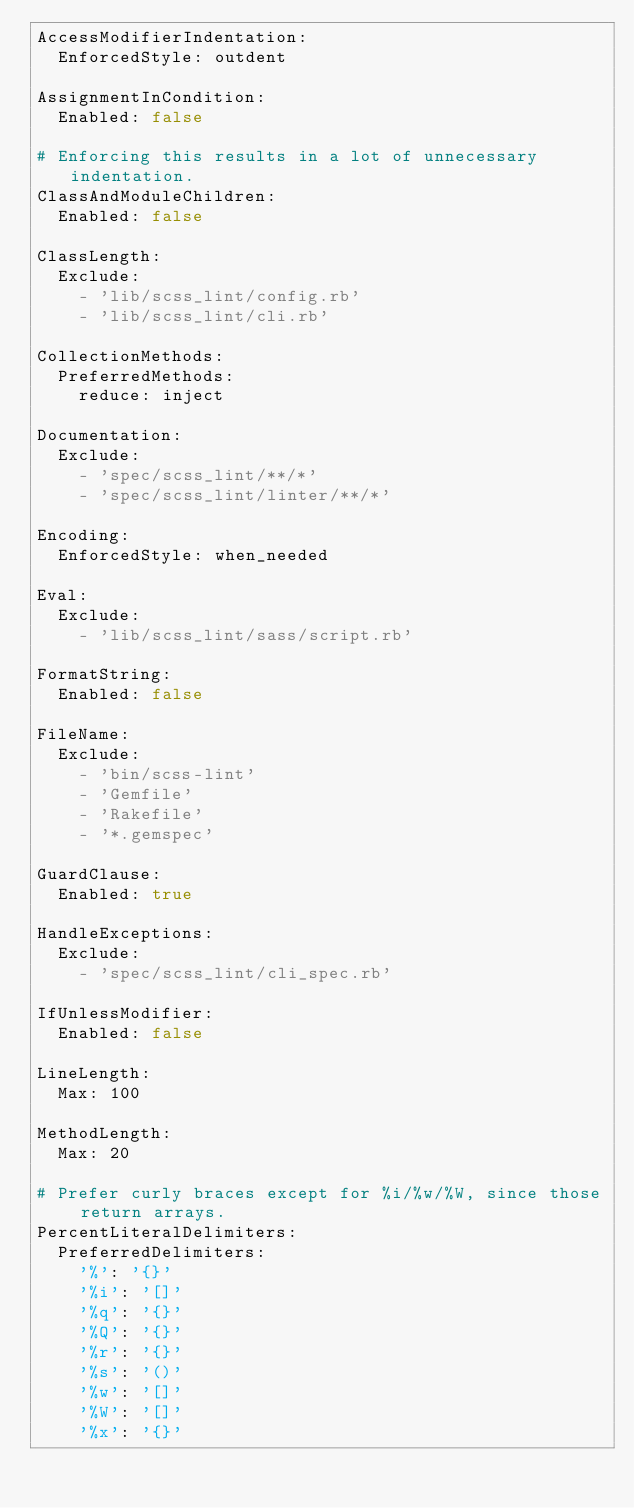<code> <loc_0><loc_0><loc_500><loc_500><_YAML_>AccessModifierIndentation:
  EnforcedStyle: outdent

AssignmentInCondition:
  Enabled: false

# Enforcing this results in a lot of unnecessary indentation.
ClassAndModuleChildren:
  Enabled: false

ClassLength:
  Exclude:
    - 'lib/scss_lint/config.rb'
    - 'lib/scss_lint/cli.rb'

CollectionMethods:
  PreferredMethods:
    reduce: inject

Documentation:
  Exclude:
    - 'spec/scss_lint/**/*'
    - 'spec/scss_lint/linter/**/*'

Encoding:
  EnforcedStyle: when_needed

Eval:
  Exclude:
    - 'lib/scss_lint/sass/script.rb'

FormatString:
  Enabled: false

FileName:
  Exclude:
    - 'bin/scss-lint'
    - 'Gemfile'
    - 'Rakefile'
    - '*.gemspec'

GuardClause:
  Enabled: true

HandleExceptions:
  Exclude:
    - 'spec/scss_lint/cli_spec.rb'

IfUnlessModifier:
  Enabled: false

LineLength:
  Max: 100

MethodLength:
  Max: 20

# Prefer curly braces except for %i/%w/%W, since those return arrays.
PercentLiteralDelimiters:
  PreferredDelimiters:
    '%': '{}'
    '%i': '[]'
    '%q': '{}'
    '%Q': '{}'
    '%r': '{}'
    '%s': '()'
    '%w': '[]'
    '%W': '[]'
    '%x': '{}'
</code> 